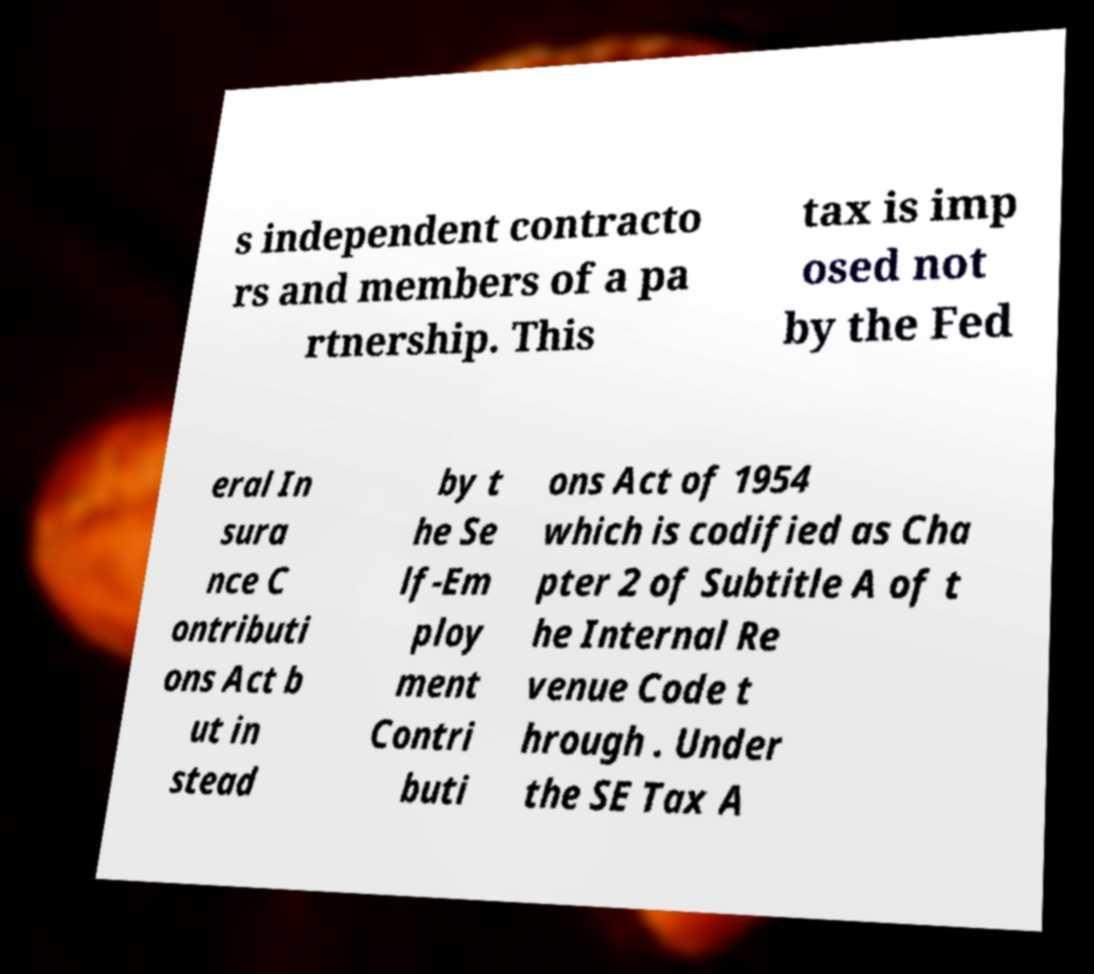What messages or text are displayed in this image? I need them in a readable, typed format. s independent contracto rs and members of a pa rtnership. This tax is imp osed not by the Fed eral In sura nce C ontributi ons Act b ut in stead by t he Se lf-Em ploy ment Contri buti ons Act of 1954 which is codified as Cha pter 2 of Subtitle A of t he Internal Re venue Code t hrough . Under the SE Tax A 